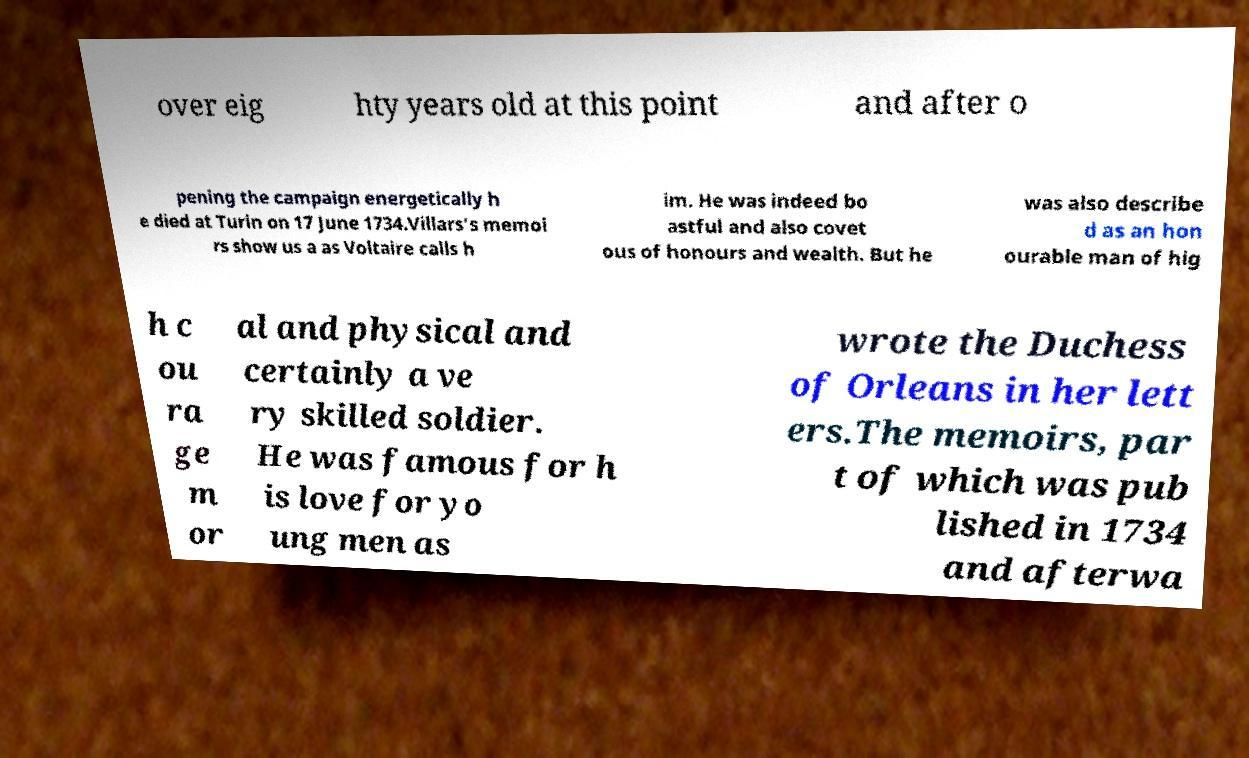There's text embedded in this image that I need extracted. Can you transcribe it verbatim? over eig hty years old at this point and after o pening the campaign energetically h e died at Turin on 17 June 1734.Villars's memoi rs show us a as Voltaire calls h im. He was indeed bo astful and also covet ous of honours and wealth. But he was also describe d as an hon ourable man of hig h c ou ra ge m or al and physical and certainly a ve ry skilled soldier. He was famous for h is love for yo ung men as wrote the Duchess of Orleans in her lett ers.The memoirs, par t of which was pub lished in 1734 and afterwa 